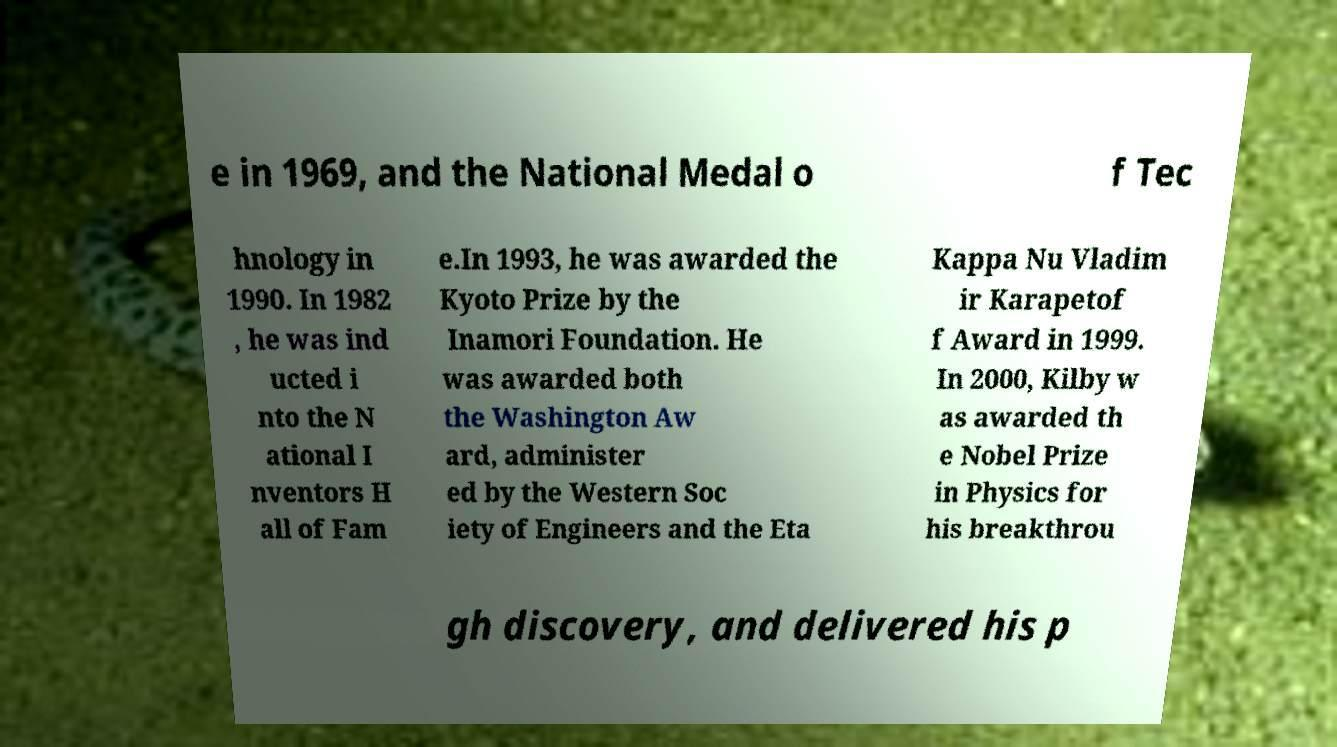Could you extract and type out the text from this image? e in 1969, and the National Medal o f Tec hnology in 1990. In 1982 , he was ind ucted i nto the N ational I nventors H all of Fam e.In 1993, he was awarded the Kyoto Prize by the Inamori Foundation. He was awarded both the Washington Aw ard, administer ed by the Western Soc iety of Engineers and the Eta Kappa Nu Vladim ir Karapetof f Award in 1999. In 2000, Kilby w as awarded th e Nobel Prize in Physics for his breakthrou gh discovery, and delivered his p 